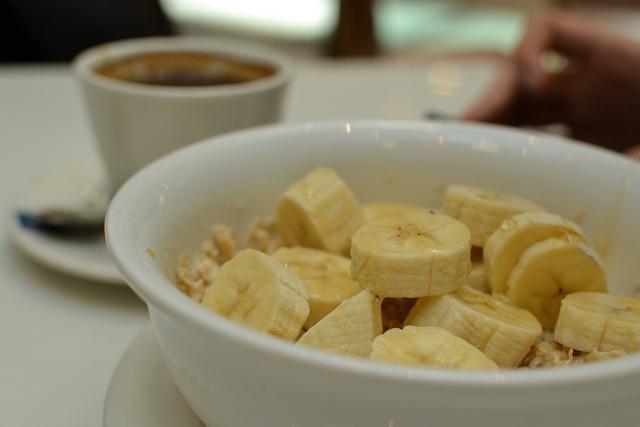Is the statement "The banana is within the bowl." accurate regarding the image?
Answer yes or no. Yes. 